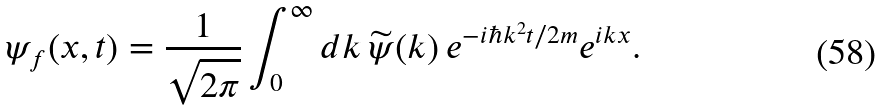<formula> <loc_0><loc_0><loc_500><loc_500>\psi _ { f } ( x , t ) = \frac { 1 } { \sqrt { 2 \pi } } \int _ { 0 } ^ { \infty } d k \, \widetilde { \psi } ( k ) \, e ^ { - i \hbar { k } ^ { 2 } t / 2 m } e ^ { i k x } .</formula> 